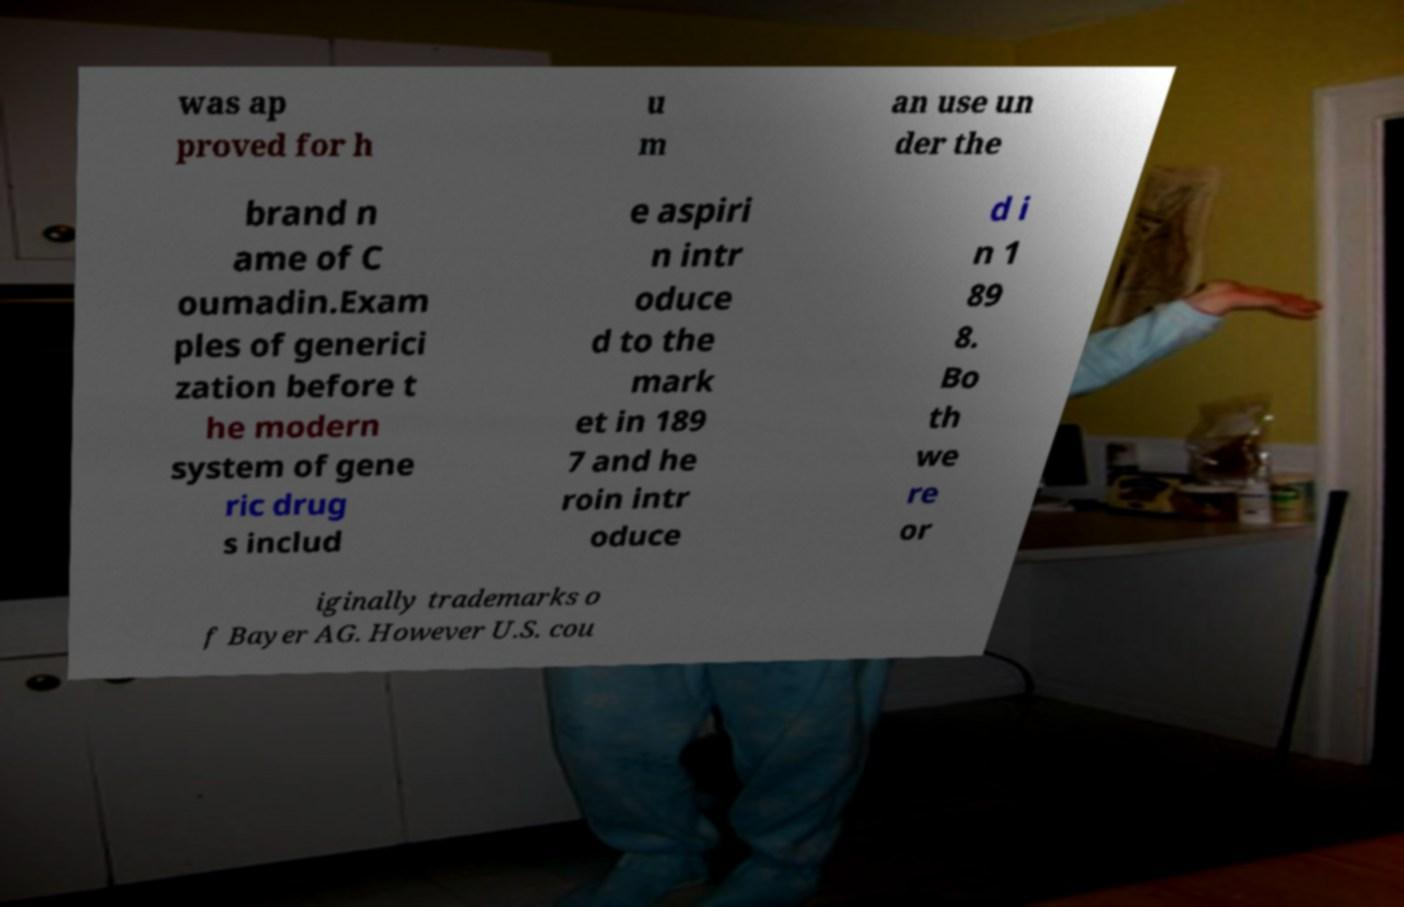Could you extract and type out the text from this image? was ap proved for h u m an use un der the brand n ame of C oumadin.Exam ples of generici zation before t he modern system of gene ric drug s includ e aspiri n intr oduce d to the mark et in 189 7 and he roin intr oduce d i n 1 89 8. Bo th we re or iginally trademarks o f Bayer AG. However U.S. cou 